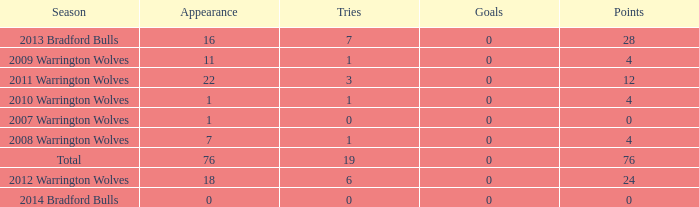What is the sum of appearance when goals is more than 0? None. 